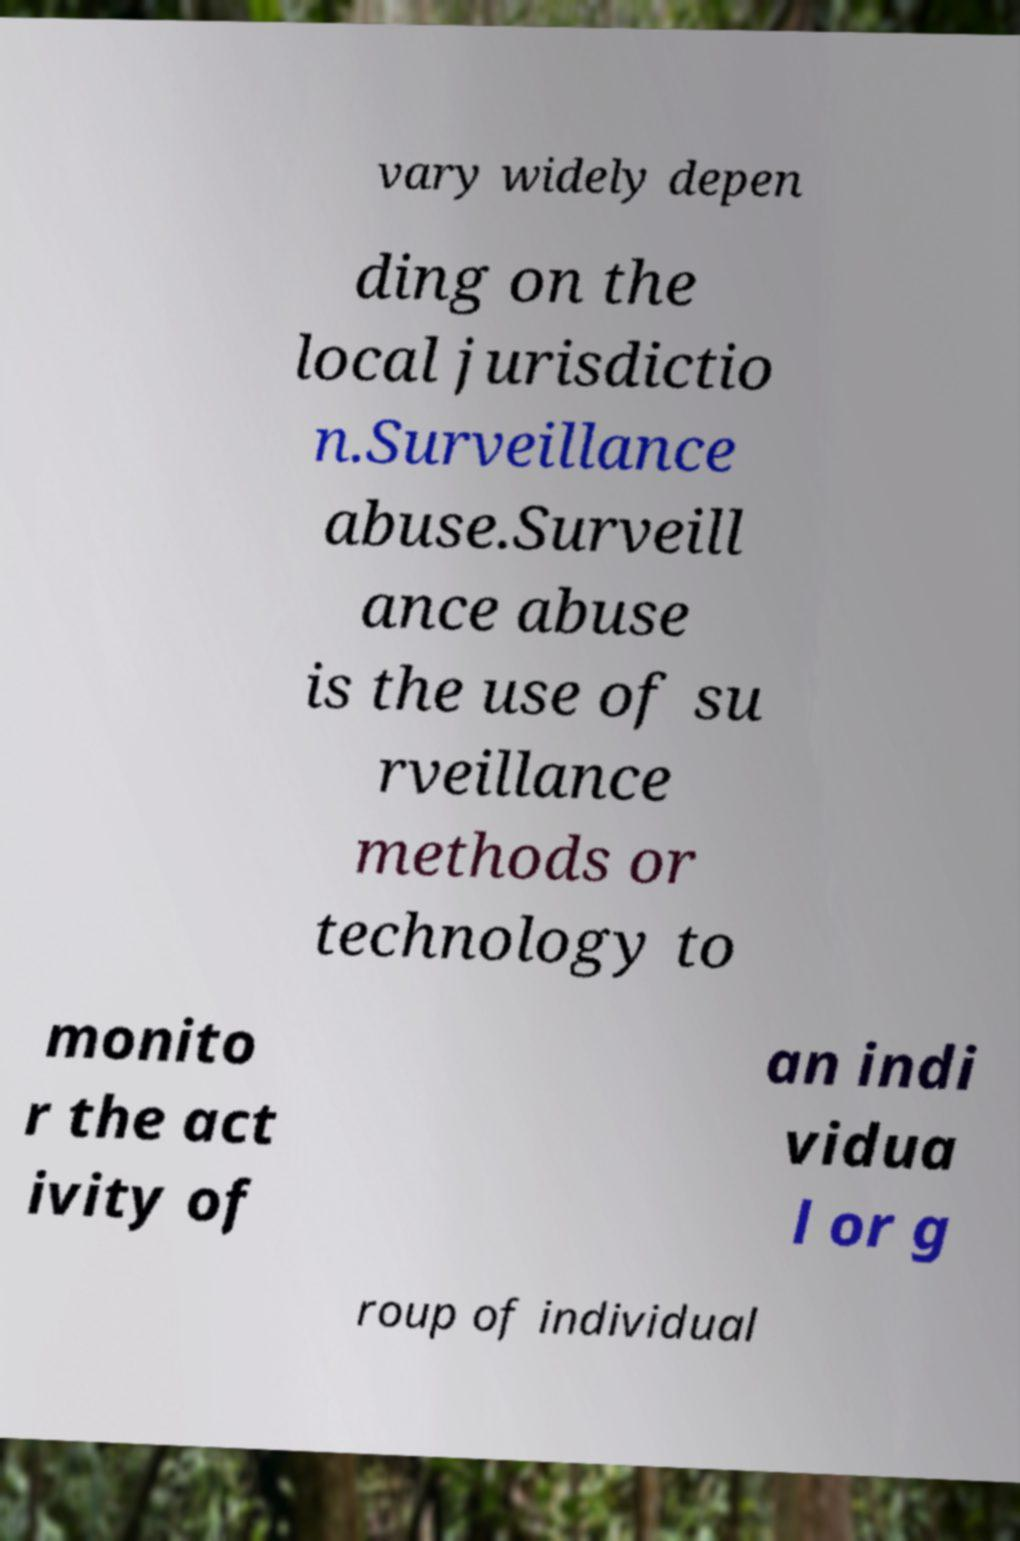There's text embedded in this image that I need extracted. Can you transcribe it verbatim? vary widely depen ding on the local jurisdictio n.Surveillance abuse.Surveill ance abuse is the use of su rveillance methods or technology to monito r the act ivity of an indi vidua l or g roup of individual 